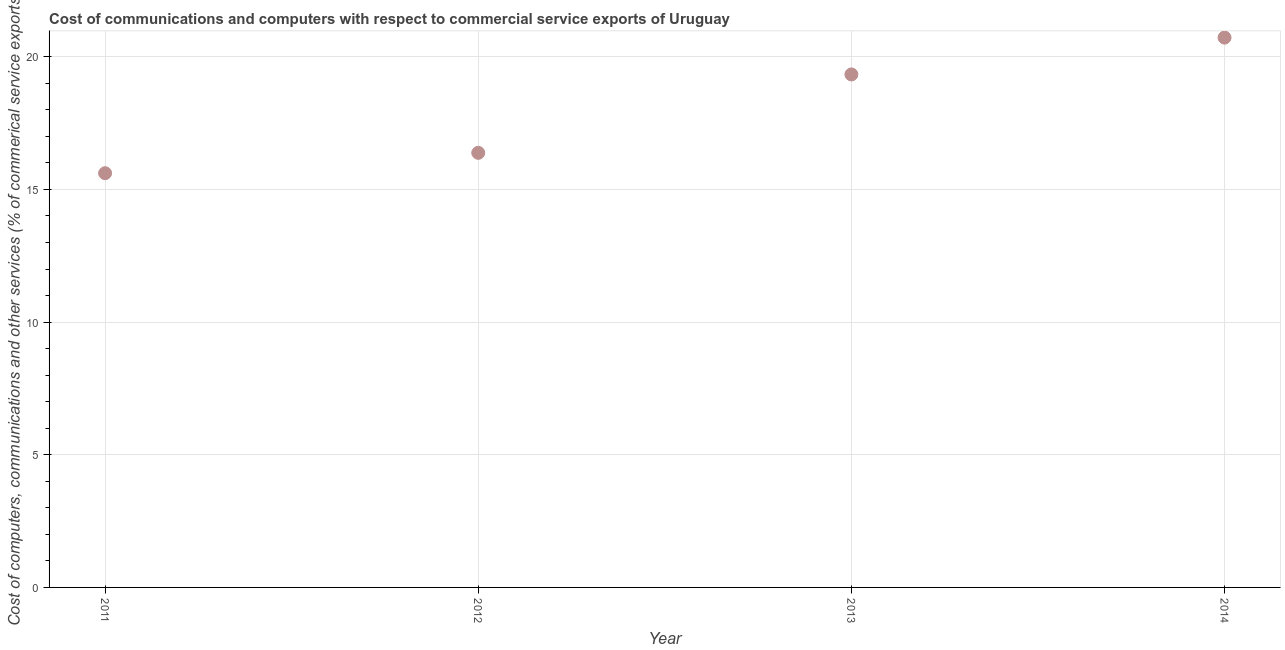What is the cost of communications in 2014?
Keep it short and to the point. 20.72. Across all years, what is the maximum cost of communications?
Provide a succinct answer. 20.72. Across all years, what is the minimum cost of communications?
Provide a succinct answer. 15.61. In which year was the  computer and other services minimum?
Make the answer very short. 2011. What is the sum of the cost of communications?
Your response must be concise. 72.05. What is the difference between the cost of communications in 2011 and 2014?
Provide a short and direct response. -5.11. What is the average cost of communications per year?
Provide a short and direct response. 18.01. What is the median cost of communications?
Your response must be concise. 17.86. In how many years, is the  computer and other services greater than 1 %?
Offer a very short reply. 4. What is the ratio of the  computer and other services in 2012 to that in 2014?
Offer a terse response. 0.79. Is the cost of communications in 2011 less than that in 2014?
Offer a very short reply. Yes. Is the difference between the  computer and other services in 2013 and 2014 greater than the difference between any two years?
Keep it short and to the point. No. What is the difference between the highest and the second highest cost of communications?
Offer a terse response. 1.39. Is the sum of the  computer and other services in 2013 and 2014 greater than the maximum  computer and other services across all years?
Offer a terse response. Yes. What is the difference between the highest and the lowest  computer and other services?
Your answer should be compact. 5.11. How many dotlines are there?
Your answer should be very brief. 1. How many years are there in the graph?
Your response must be concise. 4. Does the graph contain grids?
Provide a short and direct response. Yes. What is the title of the graph?
Your answer should be compact. Cost of communications and computers with respect to commercial service exports of Uruguay. What is the label or title of the Y-axis?
Make the answer very short. Cost of computers, communications and other services (% of commerical service exports). What is the Cost of computers, communications and other services (% of commerical service exports) in 2011?
Provide a succinct answer. 15.61. What is the Cost of computers, communications and other services (% of commerical service exports) in 2012?
Your answer should be compact. 16.38. What is the Cost of computers, communications and other services (% of commerical service exports) in 2013?
Your response must be concise. 19.33. What is the Cost of computers, communications and other services (% of commerical service exports) in 2014?
Keep it short and to the point. 20.72. What is the difference between the Cost of computers, communications and other services (% of commerical service exports) in 2011 and 2012?
Your answer should be compact. -0.77. What is the difference between the Cost of computers, communications and other services (% of commerical service exports) in 2011 and 2013?
Your response must be concise. -3.72. What is the difference between the Cost of computers, communications and other services (% of commerical service exports) in 2011 and 2014?
Provide a short and direct response. -5.11. What is the difference between the Cost of computers, communications and other services (% of commerical service exports) in 2012 and 2013?
Offer a very short reply. -2.95. What is the difference between the Cost of computers, communications and other services (% of commerical service exports) in 2012 and 2014?
Keep it short and to the point. -4.34. What is the difference between the Cost of computers, communications and other services (% of commerical service exports) in 2013 and 2014?
Make the answer very short. -1.39. What is the ratio of the Cost of computers, communications and other services (% of commerical service exports) in 2011 to that in 2012?
Offer a terse response. 0.95. What is the ratio of the Cost of computers, communications and other services (% of commerical service exports) in 2011 to that in 2013?
Provide a succinct answer. 0.81. What is the ratio of the Cost of computers, communications and other services (% of commerical service exports) in 2011 to that in 2014?
Give a very brief answer. 0.75. What is the ratio of the Cost of computers, communications and other services (% of commerical service exports) in 2012 to that in 2013?
Offer a very short reply. 0.85. What is the ratio of the Cost of computers, communications and other services (% of commerical service exports) in 2012 to that in 2014?
Keep it short and to the point. 0.79. What is the ratio of the Cost of computers, communications and other services (% of commerical service exports) in 2013 to that in 2014?
Offer a terse response. 0.93. 